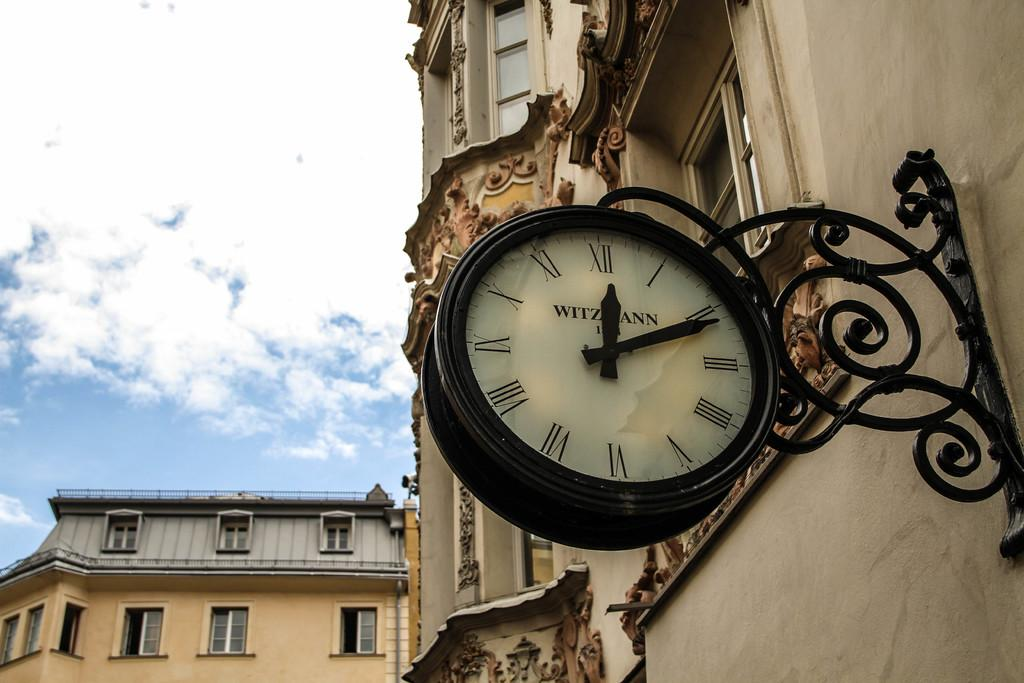<image>
Describe the image concisely. A black clock on a wall outside has the letter w on it. 